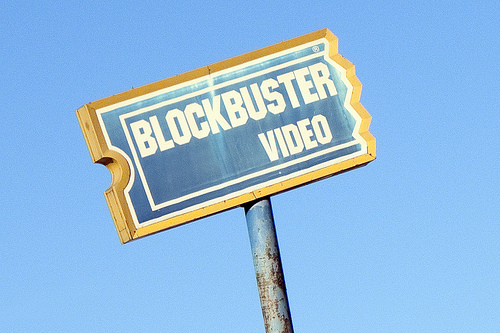<image>
Can you confirm if the sign is in the sky? No. The sign is not contained within the sky. These objects have a different spatial relationship. 